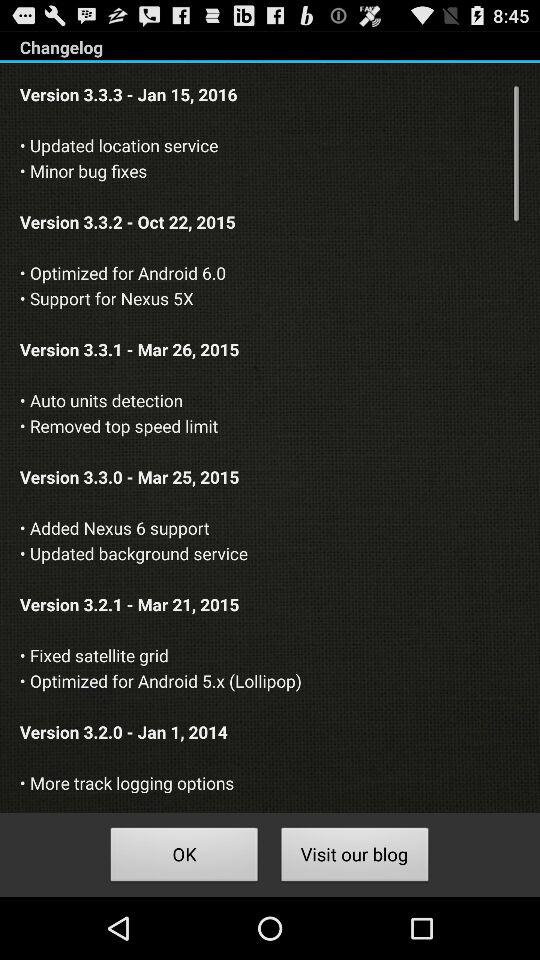Which changelog version includes "Removed top speed limit"? The changelog version is 3.3.1. 